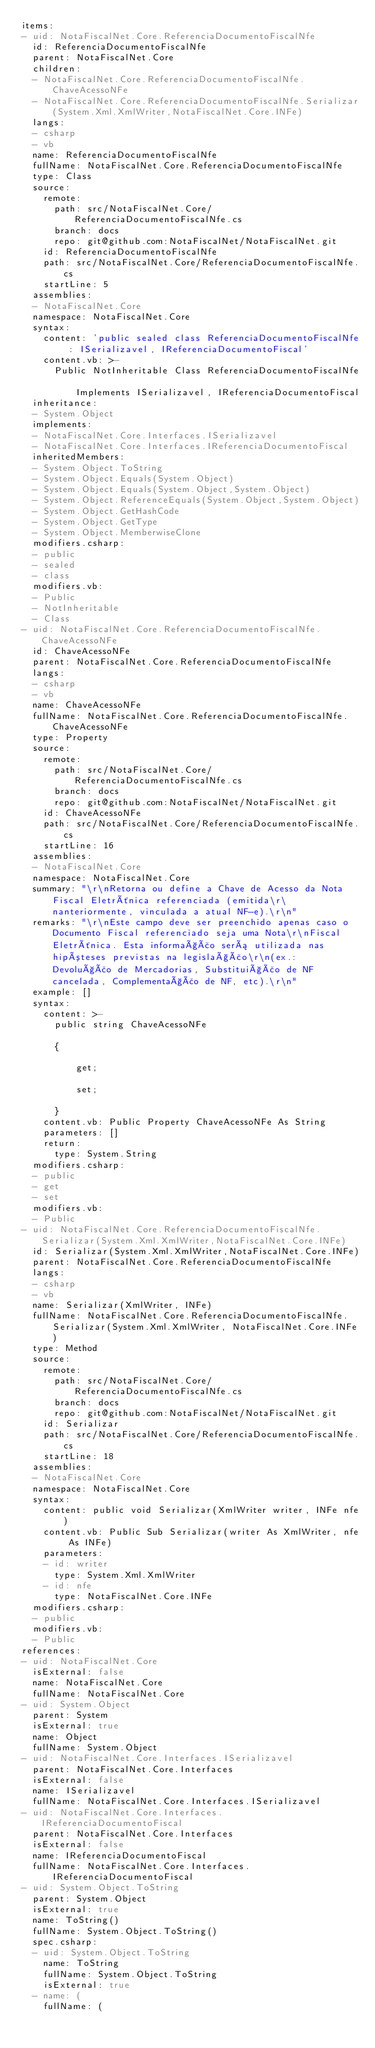Convert code to text. <code><loc_0><loc_0><loc_500><loc_500><_YAML_>items:
- uid: NotaFiscalNet.Core.ReferenciaDocumentoFiscalNfe
  id: ReferenciaDocumentoFiscalNfe
  parent: NotaFiscalNet.Core
  children:
  - NotaFiscalNet.Core.ReferenciaDocumentoFiscalNfe.ChaveAcessoNFe
  - NotaFiscalNet.Core.ReferenciaDocumentoFiscalNfe.Serializar(System.Xml.XmlWriter,NotaFiscalNet.Core.INFe)
  langs:
  - csharp
  - vb
  name: ReferenciaDocumentoFiscalNfe
  fullName: NotaFiscalNet.Core.ReferenciaDocumentoFiscalNfe
  type: Class
  source:
    remote:
      path: src/NotaFiscalNet.Core/ReferenciaDocumentoFiscalNfe.cs
      branch: docs
      repo: git@github.com:NotaFiscalNet/NotaFiscalNet.git
    id: ReferenciaDocumentoFiscalNfe
    path: src/NotaFiscalNet.Core/ReferenciaDocumentoFiscalNfe.cs
    startLine: 5
  assemblies:
  - NotaFiscalNet.Core
  namespace: NotaFiscalNet.Core
  syntax:
    content: 'public sealed class ReferenciaDocumentoFiscalNfe : ISerializavel, IReferenciaDocumentoFiscal'
    content.vb: >-
      Public NotInheritable Class ReferenciaDocumentoFiscalNfe

          Implements ISerializavel, IReferenciaDocumentoFiscal
  inheritance:
  - System.Object
  implements:
  - NotaFiscalNet.Core.Interfaces.ISerializavel
  - NotaFiscalNet.Core.Interfaces.IReferenciaDocumentoFiscal
  inheritedMembers:
  - System.Object.ToString
  - System.Object.Equals(System.Object)
  - System.Object.Equals(System.Object,System.Object)
  - System.Object.ReferenceEquals(System.Object,System.Object)
  - System.Object.GetHashCode
  - System.Object.GetType
  - System.Object.MemberwiseClone
  modifiers.csharp:
  - public
  - sealed
  - class
  modifiers.vb:
  - Public
  - NotInheritable
  - Class
- uid: NotaFiscalNet.Core.ReferenciaDocumentoFiscalNfe.ChaveAcessoNFe
  id: ChaveAcessoNFe
  parent: NotaFiscalNet.Core.ReferenciaDocumentoFiscalNfe
  langs:
  - csharp
  - vb
  name: ChaveAcessoNFe
  fullName: NotaFiscalNet.Core.ReferenciaDocumentoFiscalNfe.ChaveAcessoNFe
  type: Property
  source:
    remote:
      path: src/NotaFiscalNet.Core/ReferenciaDocumentoFiscalNfe.cs
      branch: docs
      repo: git@github.com:NotaFiscalNet/NotaFiscalNet.git
    id: ChaveAcessoNFe
    path: src/NotaFiscalNet.Core/ReferenciaDocumentoFiscalNfe.cs
    startLine: 16
  assemblies:
  - NotaFiscalNet.Core
  namespace: NotaFiscalNet.Core
  summary: "\r\nRetorna ou define a Chave de Acesso da Nota Fiscal Eletrônica referenciada (emitida\r\nanteriormente, vinculada a atual NF-e).\r\n"
  remarks: "\r\nEste campo deve ser preenchido apenas caso o Documento Fiscal referenciado seja uma Nota\r\nFiscal Eletrônica. Esta informação será utilizada nas hipóteses previstas na legislação\r\n(ex.: Devolução de Mercadorias, Substituição de NF cancelada, Complementação de NF, etc).\r\n"
  example: []
  syntax:
    content: >-
      public string ChaveAcessoNFe

      {

          get;

          set;

      }
    content.vb: Public Property ChaveAcessoNFe As String
    parameters: []
    return:
      type: System.String
  modifiers.csharp:
  - public
  - get
  - set
  modifiers.vb:
  - Public
- uid: NotaFiscalNet.Core.ReferenciaDocumentoFiscalNfe.Serializar(System.Xml.XmlWriter,NotaFiscalNet.Core.INFe)
  id: Serializar(System.Xml.XmlWriter,NotaFiscalNet.Core.INFe)
  parent: NotaFiscalNet.Core.ReferenciaDocumentoFiscalNfe
  langs:
  - csharp
  - vb
  name: Serializar(XmlWriter, INFe)
  fullName: NotaFiscalNet.Core.ReferenciaDocumentoFiscalNfe.Serializar(System.Xml.XmlWriter, NotaFiscalNet.Core.INFe)
  type: Method
  source:
    remote:
      path: src/NotaFiscalNet.Core/ReferenciaDocumentoFiscalNfe.cs
      branch: docs
      repo: git@github.com:NotaFiscalNet/NotaFiscalNet.git
    id: Serializar
    path: src/NotaFiscalNet.Core/ReferenciaDocumentoFiscalNfe.cs
    startLine: 18
  assemblies:
  - NotaFiscalNet.Core
  namespace: NotaFiscalNet.Core
  syntax:
    content: public void Serializar(XmlWriter writer, INFe nfe)
    content.vb: Public Sub Serializar(writer As XmlWriter, nfe As INFe)
    parameters:
    - id: writer
      type: System.Xml.XmlWriter
    - id: nfe
      type: NotaFiscalNet.Core.INFe
  modifiers.csharp:
  - public
  modifiers.vb:
  - Public
references:
- uid: NotaFiscalNet.Core
  isExternal: false
  name: NotaFiscalNet.Core
  fullName: NotaFiscalNet.Core
- uid: System.Object
  parent: System
  isExternal: true
  name: Object
  fullName: System.Object
- uid: NotaFiscalNet.Core.Interfaces.ISerializavel
  parent: NotaFiscalNet.Core.Interfaces
  isExternal: false
  name: ISerializavel
  fullName: NotaFiscalNet.Core.Interfaces.ISerializavel
- uid: NotaFiscalNet.Core.Interfaces.IReferenciaDocumentoFiscal
  parent: NotaFiscalNet.Core.Interfaces
  isExternal: false
  name: IReferenciaDocumentoFiscal
  fullName: NotaFiscalNet.Core.Interfaces.IReferenciaDocumentoFiscal
- uid: System.Object.ToString
  parent: System.Object
  isExternal: true
  name: ToString()
  fullName: System.Object.ToString()
  spec.csharp:
  - uid: System.Object.ToString
    name: ToString
    fullName: System.Object.ToString
    isExternal: true
  - name: (
    fullName: (</code> 